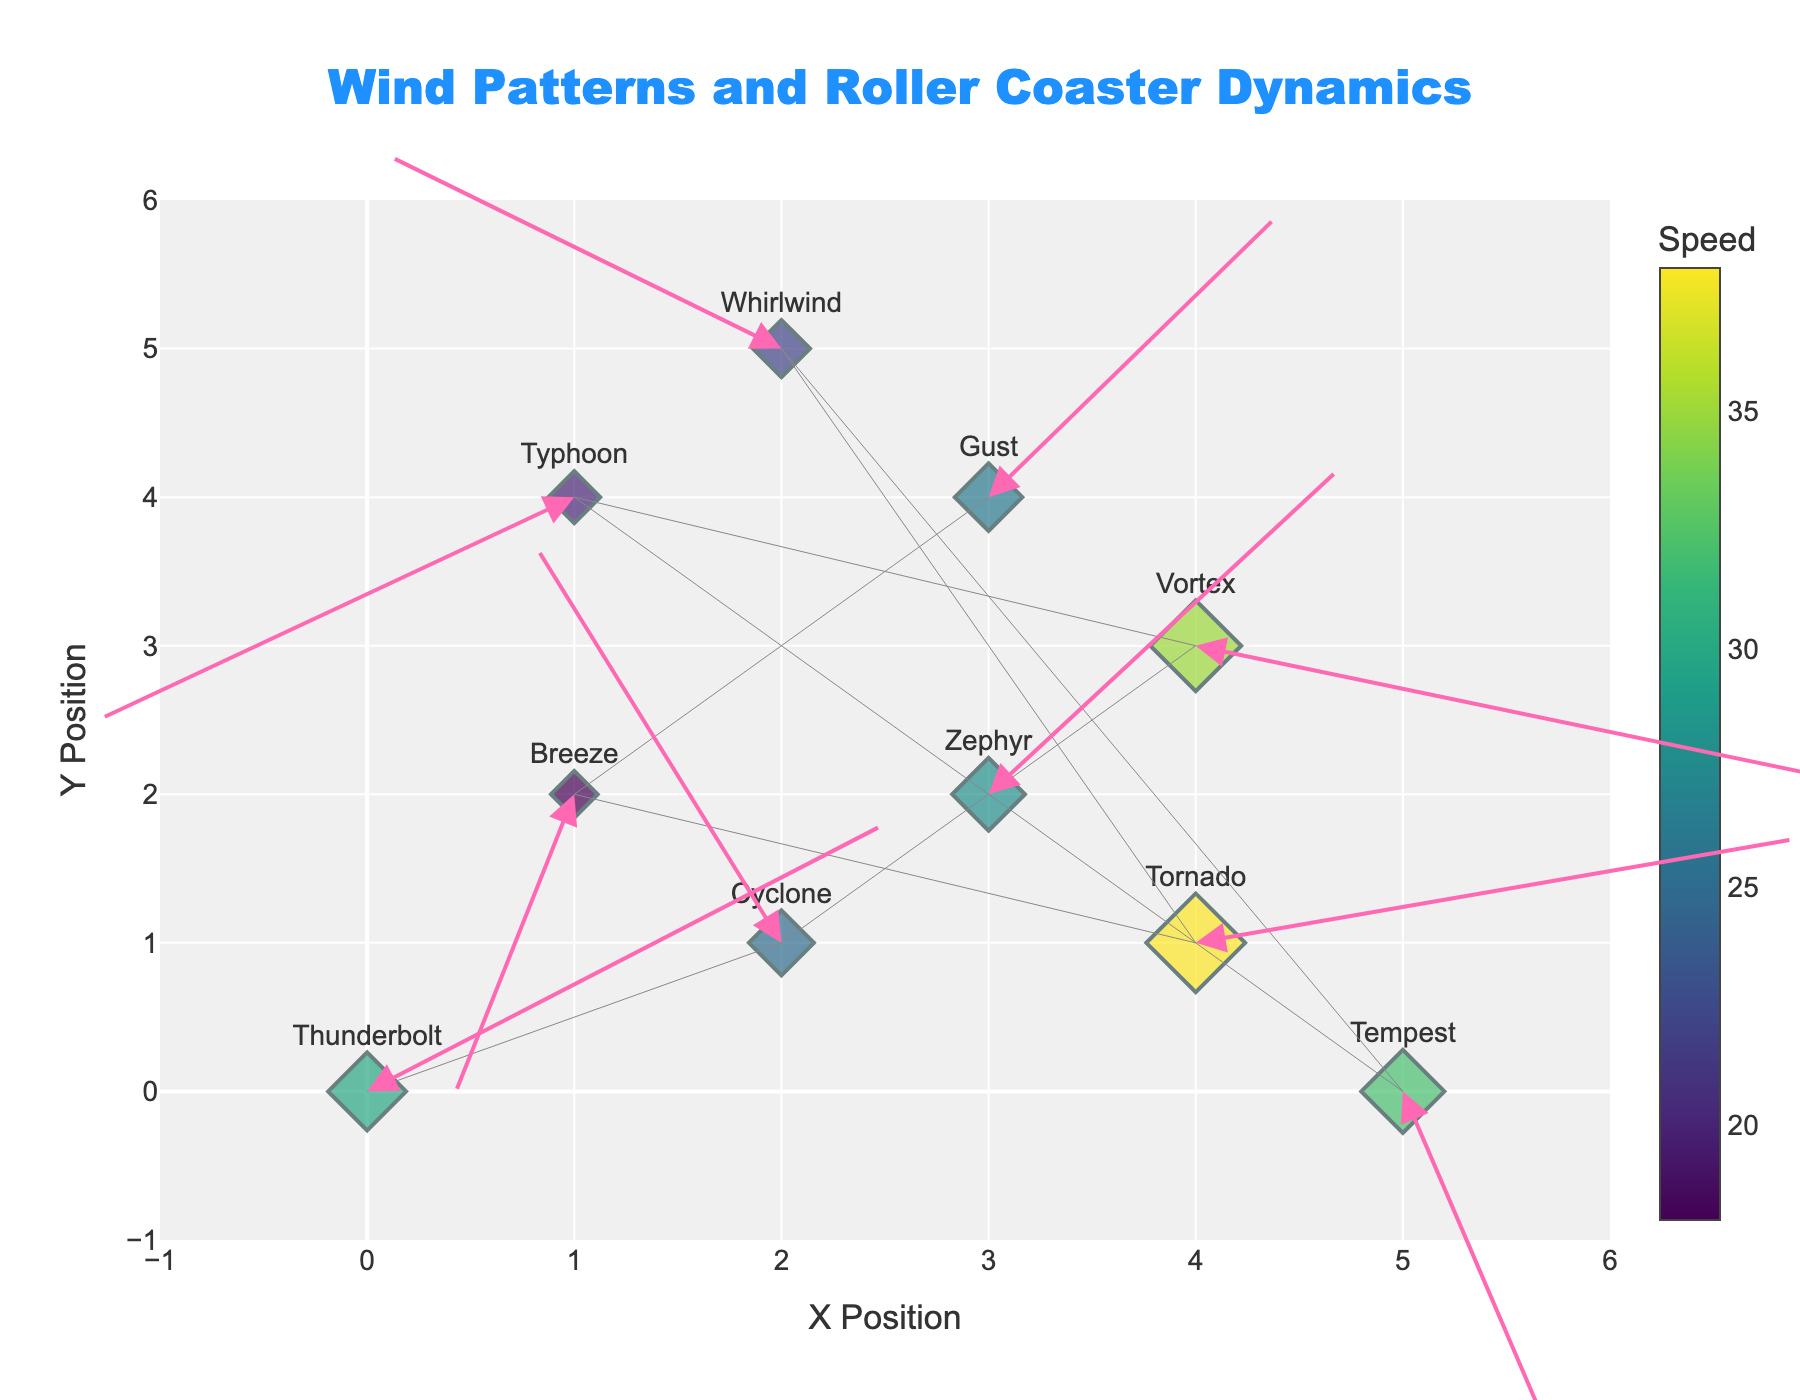What is the title of the plot? The title is located at the top center of the plot and reads "Wind Patterns and Roller Coaster Dynamics".
Answer: Wind Patterns and Roller Coaster Dynamics What is the color scale used for the marker colors? The markers are colored using a gradient color scale called 'Viridis', which ranges from dark purple to yellow. This can be seen from the color gradient on the markers.
Answer: Viridis How many roller coasters are represented in the plot? By counting the text labels on the plot that correspond to different roller coaster names, we can determine the number of roller coasters. There are 10 roller coasters in total.
Answer: 10 Which roller coaster has the highest speed and what is that speed? The colorbar indicates the speed. Identifying the coaster with the most intense color on the Viridis scale, Tornado has the brightest color, which corresponds to 38.
Answer: Tornado, 38 How do the wind vectors for Thunderbolt and Tempest compare in direction? Observing the arrows, Thunderbolt’s wind vector points upwards and slightly to the right, while Tempest’s vector points downwards and to the right. They have almost opposite vertical directions.
Answer: Opposite vertical directions Which roller coaster experiences the strongest wind vector magnitude, and how can you tell? The magnitude of the wind vectors (U, V) can be visually estimated by the length of the arrows. Vortex has the longest arrow, suggesting it experiences the strongest wind vector magnitude.
Answer: Vortex What is the relationship between the positions (X, Y) and the speeds of the roller coasters? By visual observation, there is no clear linear relationship between the positions and speeds of the roller coasters, suggesting these factors are independent.
Answer: No clear relationship Compare the wind vector magnitudes for Cyclone and Typhoon. Which one is larger? Compute the magnitudes using the formula √(U^2 + V^2). Cyclone: √((-1.2)^2 + 2.7^2) ≈ 2.98, Typhoon: √((-2.3)^2 + (-1.5)^2) ≈ 2.75. Cyclone has a larger magnitude.
Answer: Cyclone Which coaster has a wind vector with almost no vertical component? The wind vector with the smallest V component is for Vortex, where V = -0.9.
Answer: Vortex Which roller coaster has a wind vector pointing generally leftwards? Leftward vectors have negative U values. Both Typhoon (U=-2.3) and Whirlwind (U=-1.9) point left, but Typhoon’s vector is more vertically downward.
Answer: Typhoon, Whirlwind 